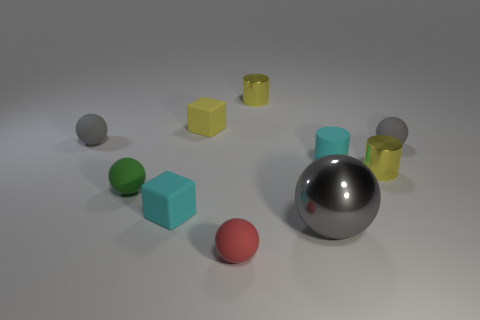Are there the same number of yellow matte blocks on the right side of the cyan cylinder and small green things right of the shiny ball?
Ensure brevity in your answer.  Yes. There is a large thing that is the same shape as the tiny green rubber object; what is its color?
Give a very brief answer. Gray. What number of matte objects have the same color as the rubber cylinder?
Your response must be concise. 1. There is a tiny metal object that is behind the small yellow rubber object; is its shape the same as the gray metallic object?
Offer a very short reply. No. There is a cyan rubber object that is to the right of the small matte cube that is behind the small gray thing right of the tiny cyan block; what is its shape?
Offer a terse response. Cylinder. What size is the green rubber ball?
Provide a succinct answer. Small. There is another cube that is the same material as the small yellow cube; what color is it?
Your answer should be compact. Cyan. What number of large gray objects are made of the same material as the green ball?
Offer a terse response. 0. Does the small matte cylinder have the same color as the small shiny cylinder left of the gray shiny object?
Offer a very short reply. No. The small metallic thing that is in front of the cyan object that is behind the cyan cube is what color?
Ensure brevity in your answer.  Yellow. 